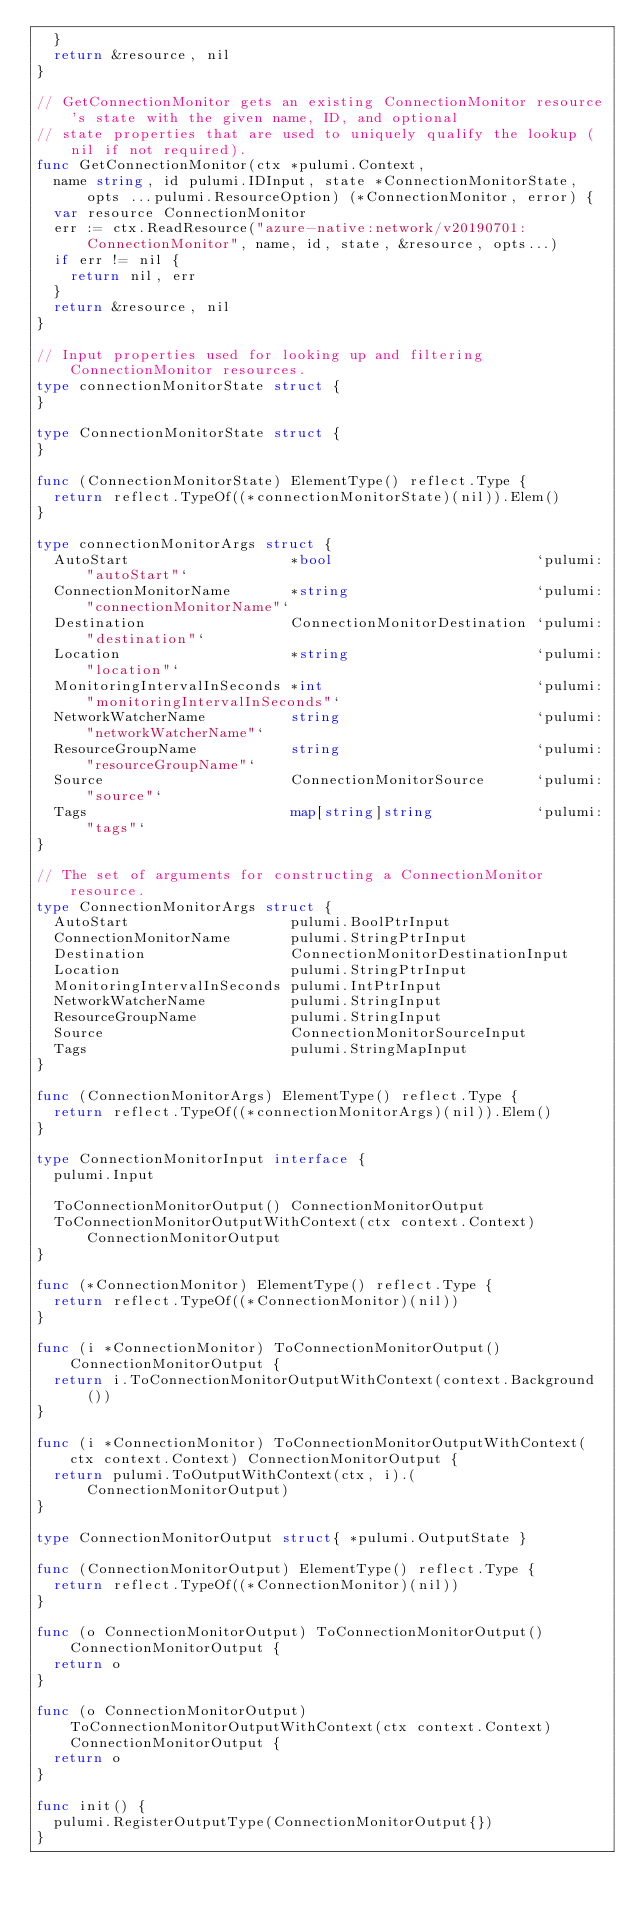Convert code to text. <code><loc_0><loc_0><loc_500><loc_500><_Go_>	}
	return &resource, nil
}

// GetConnectionMonitor gets an existing ConnectionMonitor resource's state with the given name, ID, and optional
// state properties that are used to uniquely qualify the lookup (nil if not required).
func GetConnectionMonitor(ctx *pulumi.Context,
	name string, id pulumi.IDInput, state *ConnectionMonitorState, opts ...pulumi.ResourceOption) (*ConnectionMonitor, error) {
	var resource ConnectionMonitor
	err := ctx.ReadResource("azure-native:network/v20190701:ConnectionMonitor", name, id, state, &resource, opts...)
	if err != nil {
		return nil, err
	}
	return &resource, nil
}

// Input properties used for looking up and filtering ConnectionMonitor resources.
type connectionMonitorState struct {
}

type ConnectionMonitorState struct {
}

func (ConnectionMonitorState) ElementType() reflect.Type {
	return reflect.TypeOf((*connectionMonitorState)(nil)).Elem()
}

type connectionMonitorArgs struct {
	AutoStart                   *bool                        `pulumi:"autoStart"`
	ConnectionMonitorName       *string                      `pulumi:"connectionMonitorName"`
	Destination                 ConnectionMonitorDestination `pulumi:"destination"`
	Location                    *string                      `pulumi:"location"`
	MonitoringIntervalInSeconds *int                         `pulumi:"monitoringIntervalInSeconds"`
	NetworkWatcherName          string                       `pulumi:"networkWatcherName"`
	ResourceGroupName           string                       `pulumi:"resourceGroupName"`
	Source                      ConnectionMonitorSource      `pulumi:"source"`
	Tags                        map[string]string            `pulumi:"tags"`
}

// The set of arguments for constructing a ConnectionMonitor resource.
type ConnectionMonitorArgs struct {
	AutoStart                   pulumi.BoolPtrInput
	ConnectionMonitorName       pulumi.StringPtrInput
	Destination                 ConnectionMonitorDestinationInput
	Location                    pulumi.StringPtrInput
	MonitoringIntervalInSeconds pulumi.IntPtrInput
	NetworkWatcherName          pulumi.StringInput
	ResourceGroupName           pulumi.StringInput
	Source                      ConnectionMonitorSourceInput
	Tags                        pulumi.StringMapInput
}

func (ConnectionMonitorArgs) ElementType() reflect.Type {
	return reflect.TypeOf((*connectionMonitorArgs)(nil)).Elem()
}

type ConnectionMonitorInput interface {
	pulumi.Input

	ToConnectionMonitorOutput() ConnectionMonitorOutput
	ToConnectionMonitorOutputWithContext(ctx context.Context) ConnectionMonitorOutput
}

func (*ConnectionMonitor) ElementType() reflect.Type {
	return reflect.TypeOf((*ConnectionMonitor)(nil))
}

func (i *ConnectionMonitor) ToConnectionMonitorOutput() ConnectionMonitorOutput {
	return i.ToConnectionMonitorOutputWithContext(context.Background())
}

func (i *ConnectionMonitor) ToConnectionMonitorOutputWithContext(ctx context.Context) ConnectionMonitorOutput {
	return pulumi.ToOutputWithContext(ctx, i).(ConnectionMonitorOutput)
}

type ConnectionMonitorOutput struct{ *pulumi.OutputState }

func (ConnectionMonitorOutput) ElementType() reflect.Type {
	return reflect.TypeOf((*ConnectionMonitor)(nil))
}

func (o ConnectionMonitorOutput) ToConnectionMonitorOutput() ConnectionMonitorOutput {
	return o
}

func (o ConnectionMonitorOutput) ToConnectionMonitorOutputWithContext(ctx context.Context) ConnectionMonitorOutput {
	return o
}

func init() {
	pulumi.RegisterOutputType(ConnectionMonitorOutput{})
}
</code> 